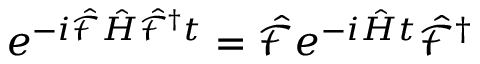<formula> <loc_0><loc_0><loc_500><loc_500>e ^ { - i \hat { \mathcal { F } } \hat { H } \hat { \mathcal { F } } ^ { \dagger } t } = \hat { \mathcal { F } } e ^ { - i \hat { H } t } \hat { \mathcal { F } } ^ { \dagger }</formula> 